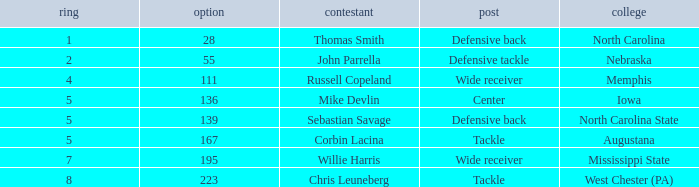What is the sum of Round with a Position that is center? 5.0. 